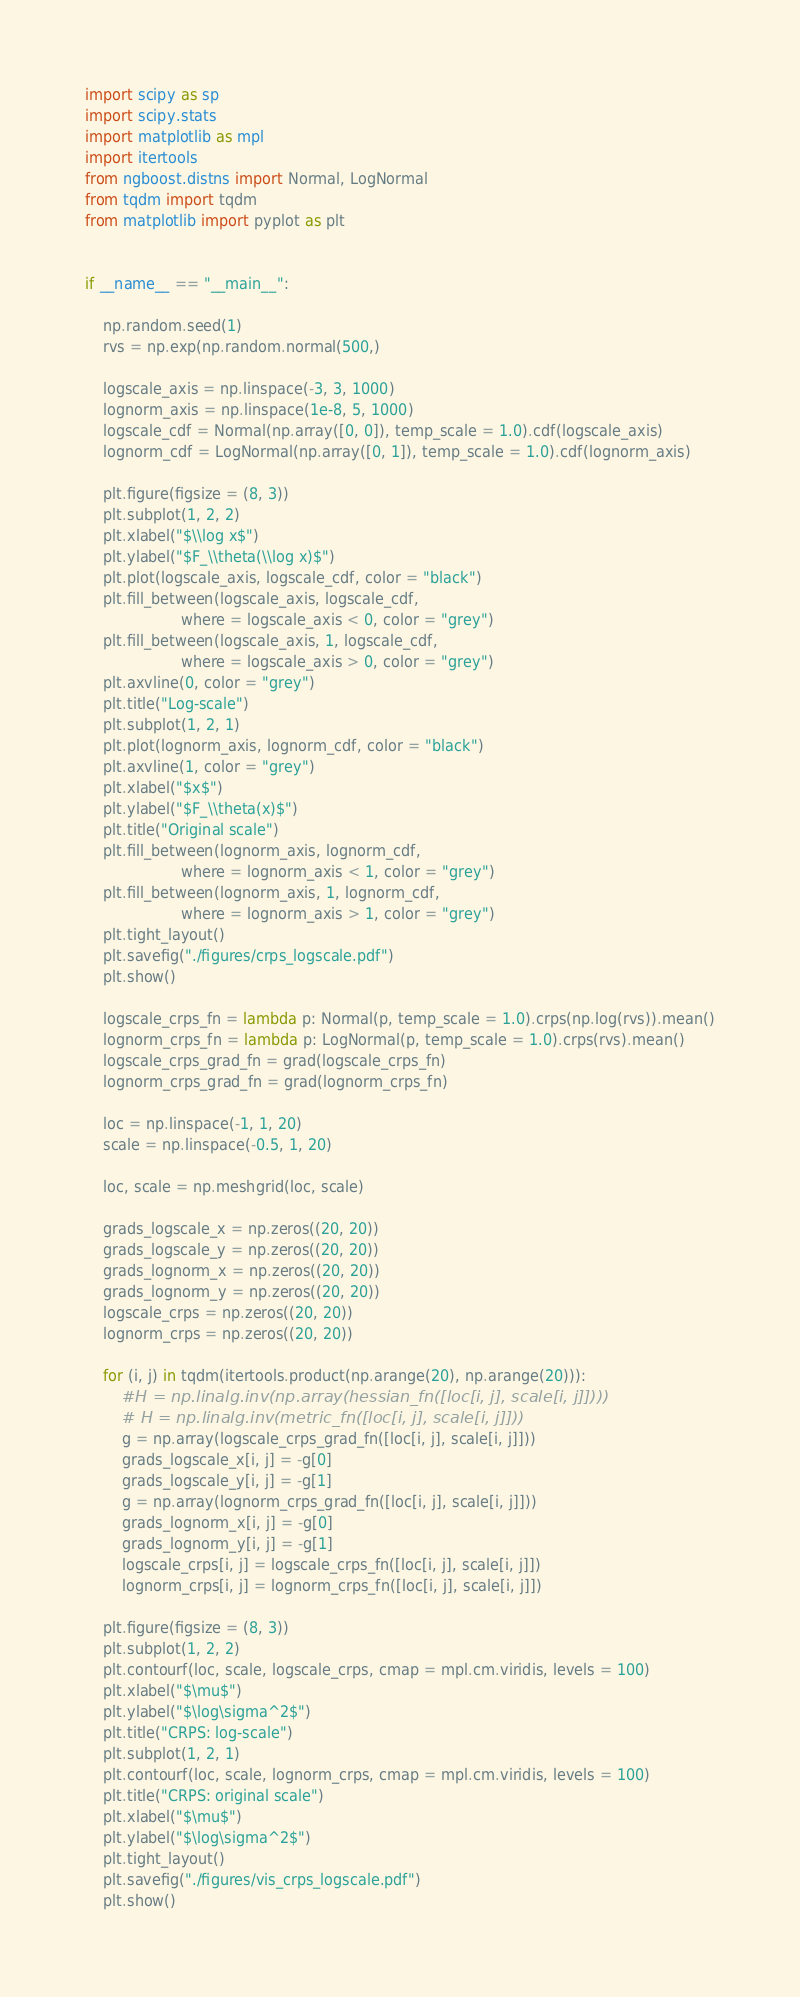Convert code to text. <code><loc_0><loc_0><loc_500><loc_500><_Python_>import scipy as sp
import scipy.stats
import matplotlib as mpl
import itertools
from ngboost.distns import Normal, LogNormal
from tqdm import tqdm
from matplotlib import pyplot as plt


if __name__ == "__main__":

    np.random.seed(1)
    rvs = np.exp(np.random.normal(500,)

    logscale_axis = np.linspace(-3, 3, 1000)
    lognorm_axis = np.linspace(1e-8, 5, 1000)
    logscale_cdf = Normal(np.array([0, 0]), temp_scale = 1.0).cdf(logscale_axis)
    lognorm_cdf = LogNormal(np.array([0, 1]), temp_scale = 1.0).cdf(lognorm_axis)

    plt.figure(figsize = (8, 3))
    plt.subplot(1, 2, 2)
    plt.xlabel("$\\log x$")
    plt.ylabel("$F_\\theta(\\log x)$")
    plt.plot(logscale_axis, logscale_cdf, color = "black")
    plt.fill_between(logscale_axis, logscale_cdf,
                     where = logscale_axis < 0, color = "grey")
    plt.fill_between(logscale_axis, 1, logscale_cdf,
                     where = logscale_axis > 0, color = "grey")
    plt.axvline(0, color = "grey")
    plt.title("Log-scale")
    plt.subplot(1, 2, 1)
    plt.plot(lognorm_axis, lognorm_cdf, color = "black")
    plt.axvline(1, color = "grey")
    plt.xlabel("$x$")
    plt.ylabel("$F_\\theta(x)$")
    plt.title("Original scale")
    plt.fill_between(lognorm_axis, lognorm_cdf,
                     where = lognorm_axis < 1, color = "grey")
    plt.fill_between(lognorm_axis, 1, lognorm_cdf,
                     where = lognorm_axis > 1, color = "grey")
    plt.tight_layout()
    plt.savefig("./figures/crps_logscale.pdf")
    plt.show()

    logscale_crps_fn = lambda p: Normal(p, temp_scale = 1.0).crps(np.log(rvs)).mean()
    lognorm_crps_fn = lambda p: LogNormal(p, temp_scale = 1.0).crps(rvs).mean()
    logscale_crps_grad_fn = grad(logscale_crps_fn)
    lognorm_crps_grad_fn = grad(lognorm_crps_fn)

    loc = np.linspace(-1, 1, 20)
    scale = np.linspace(-0.5, 1, 20)

    loc, scale = np.meshgrid(loc, scale)

    grads_logscale_x = np.zeros((20, 20))
    grads_logscale_y = np.zeros((20, 20))
    grads_lognorm_x = np.zeros((20, 20))
    grads_lognorm_y = np.zeros((20, 20))
    logscale_crps = np.zeros((20, 20))
    lognorm_crps = np.zeros((20, 20))

    for (i, j) in tqdm(itertools.product(np.arange(20), np.arange(20))):
        #H = np.linalg.inv(np.array(hessian_fn([loc[i, j], scale[i, j]])))
        # H = np.linalg.inv(metric_fn([loc[i, j], scale[i, j]]))
        g = np.array(logscale_crps_grad_fn([loc[i, j], scale[i, j]]))
        grads_logscale_x[i, j] = -g[0]
        grads_logscale_y[i, j] = -g[1]
        g = np.array(lognorm_crps_grad_fn([loc[i, j], scale[i, j]]))
        grads_lognorm_x[i, j] = -g[0]
        grads_lognorm_y[i, j] = -g[1]
        logscale_crps[i, j] = logscale_crps_fn([loc[i, j], scale[i, j]])
        lognorm_crps[i, j] = lognorm_crps_fn([loc[i, j], scale[i, j]])

    plt.figure(figsize = (8, 3))
    plt.subplot(1, 2, 2)
    plt.contourf(loc, scale, logscale_crps, cmap = mpl.cm.viridis, levels = 100)
    plt.xlabel("$\mu$")
    plt.ylabel("$\log\sigma^2$")
    plt.title("CRPS: log-scale")
    plt.subplot(1, 2, 1)
    plt.contourf(loc, scale, lognorm_crps, cmap = mpl.cm.viridis, levels = 100)
    plt.title("CRPS: original scale")
    plt.xlabel("$\mu$")
    plt.ylabel("$\log\sigma^2$")
    plt.tight_layout()
    plt.savefig("./figures/vis_crps_logscale.pdf")
    plt.show()
</code> 